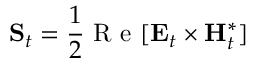<formula> <loc_0><loc_0><loc_500><loc_500>S _ { t } = \frac { 1 } { 2 } R e [ E _ { t } \times H _ { t } ^ { * } ]</formula> 